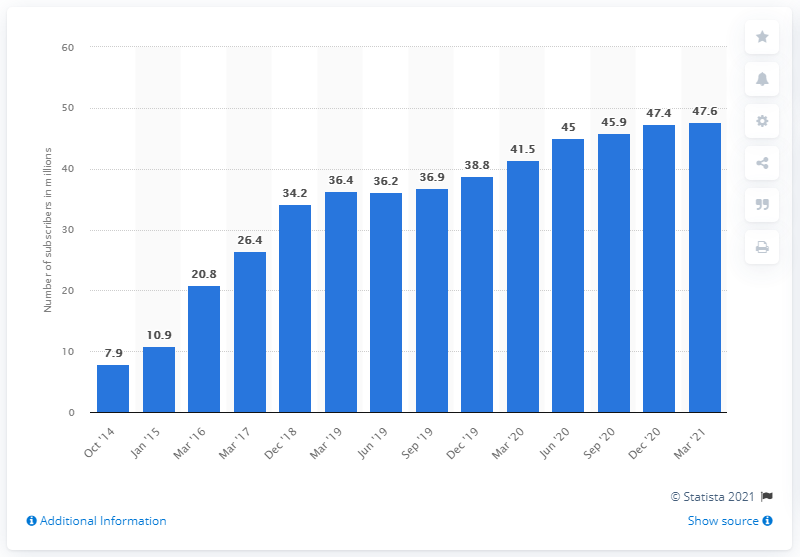Outline some significant characteristics in this image. As of March 2021, PlayStation Plus had 47.6 million subscribers. 